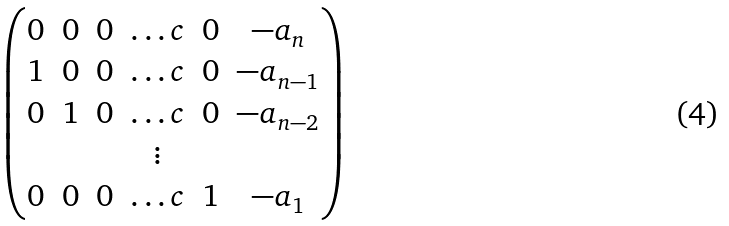Convert formula to latex. <formula><loc_0><loc_0><loc_500><loc_500>\begin{pmatrix} 0 & 0 & 0 & \dots c & 0 & - a _ { n } \\ 1 & 0 & 0 & \dots c & 0 & - a _ { n - 1 } \\ 0 & 1 & 0 & \dots c & 0 & - a _ { n - 2 } \\ & & & \vdots \\ 0 & 0 & 0 & \dots c & 1 & - a _ { 1 } \\ \end{pmatrix}</formula> 